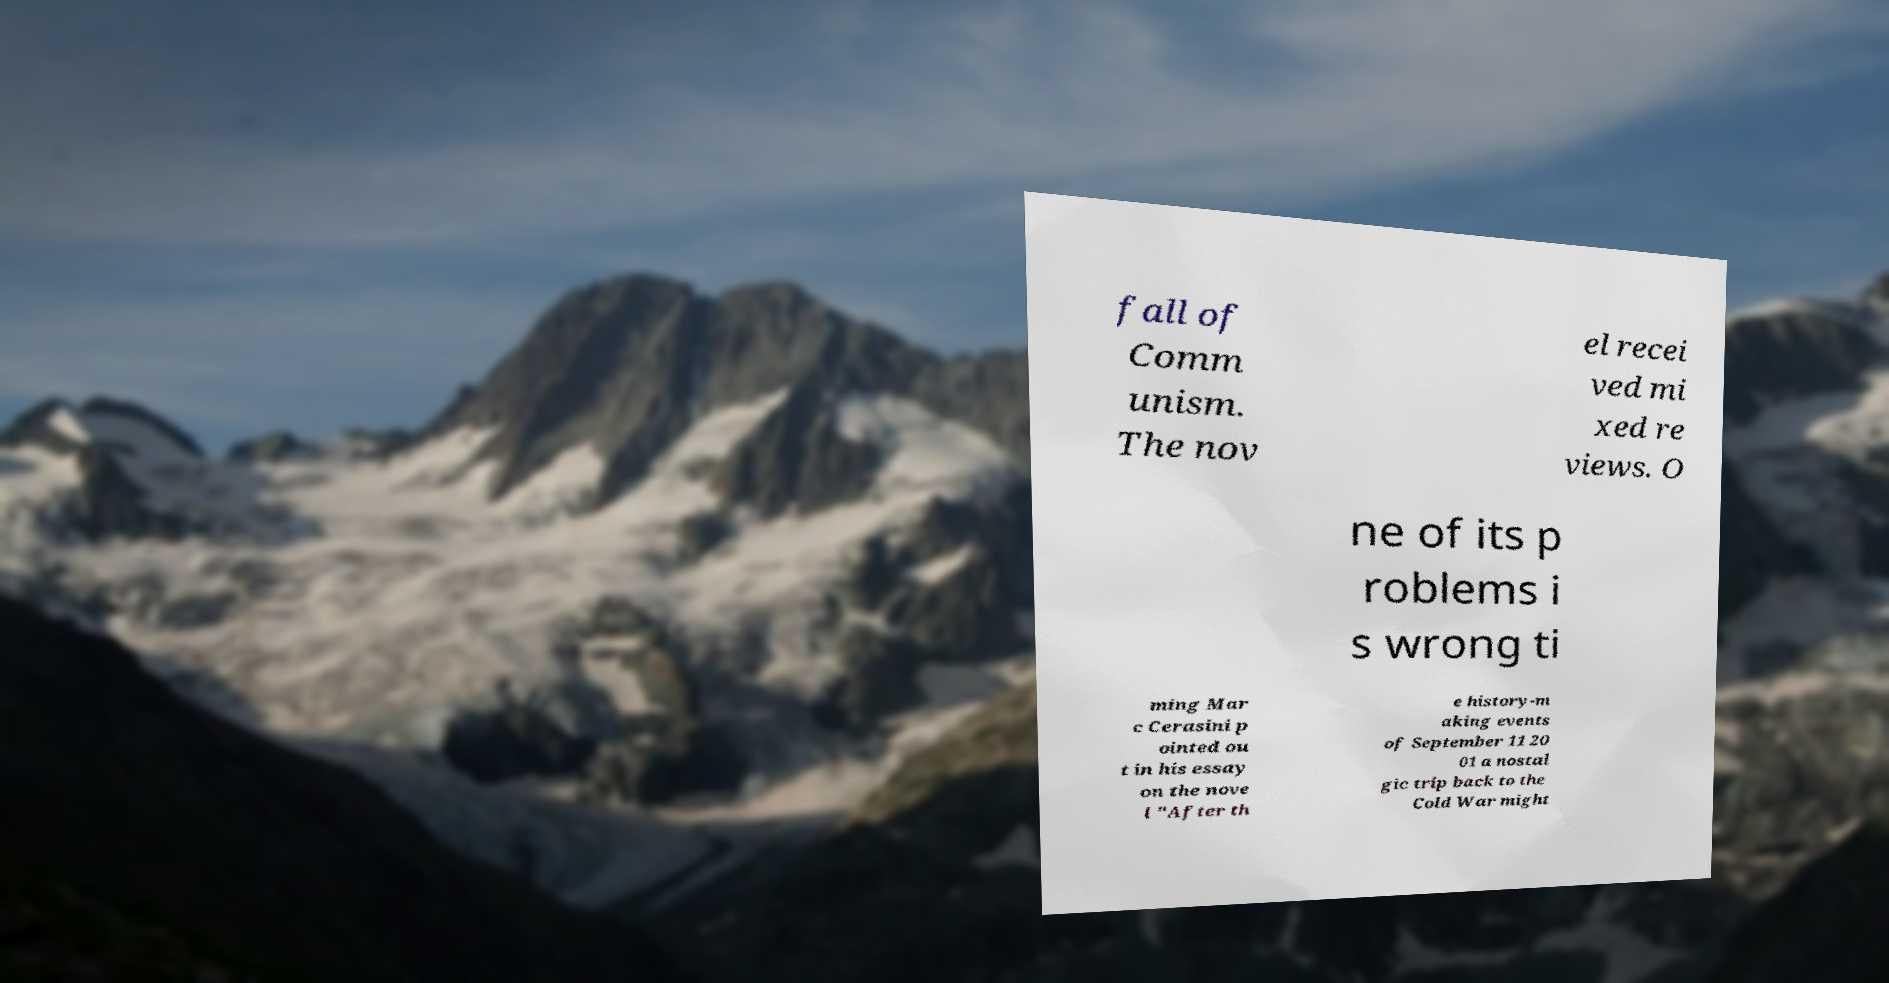Please identify and transcribe the text found in this image. fall of Comm unism. The nov el recei ved mi xed re views. O ne of its p roblems i s wrong ti ming Mar c Cerasini p ointed ou t in his essay on the nove l "After th e history-m aking events of September 11 20 01 a nostal gic trip back to the Cold War might 